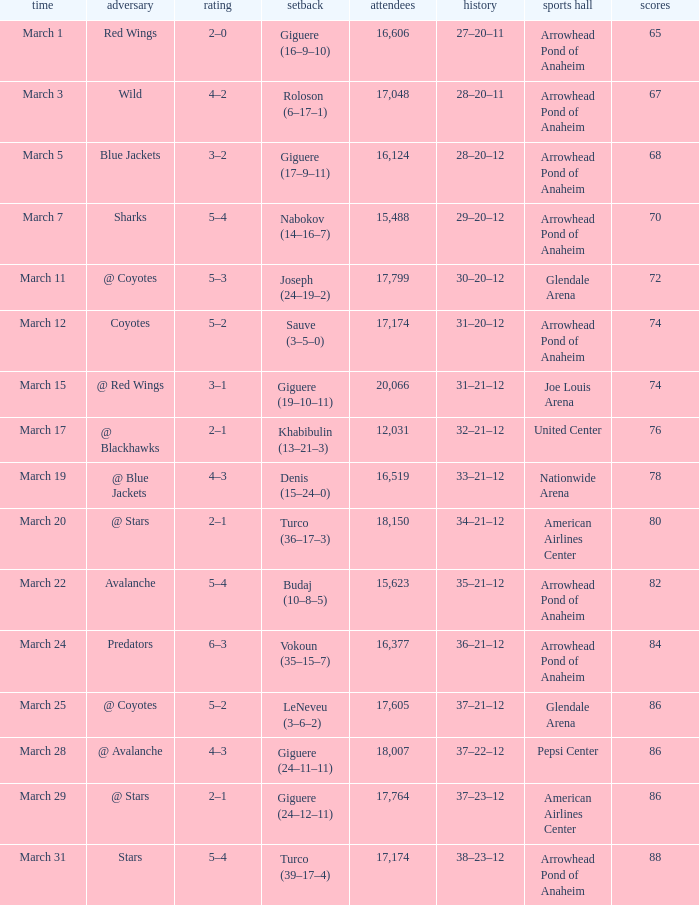What is the Attendance of the game with a Score of 3–2? 1.0. 